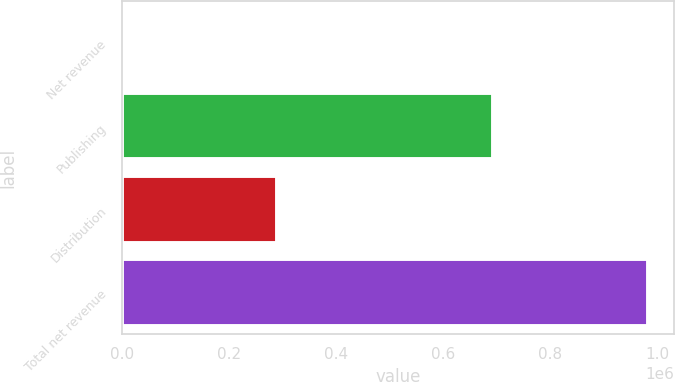<chart> <loc_0><loc_0><loc_500><loc_500><bar_chart><fcel>Net revenue<fcel>Publishing<fcel>Distribution<fcel>Total net revenue<nl><fcel>2007<fcel>692341<fcel>289450<fcel>981791<nl></chart> 